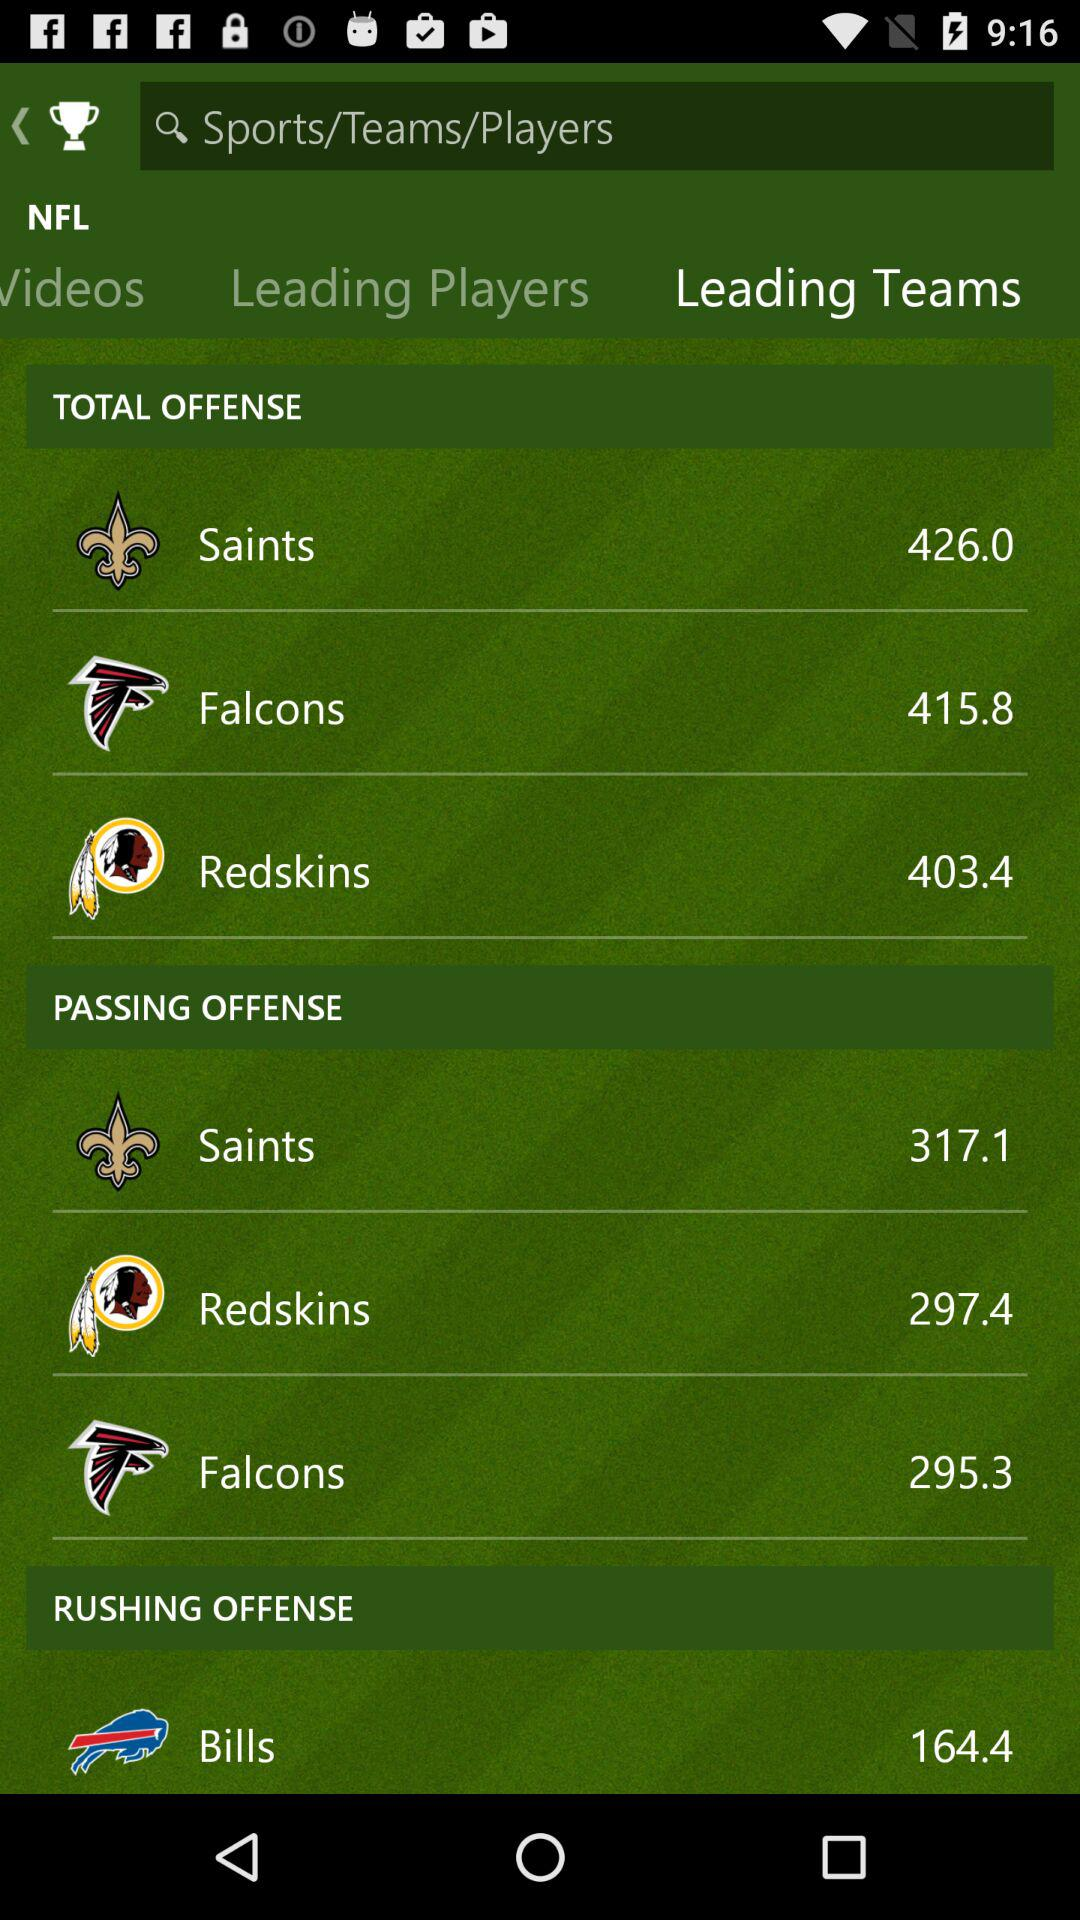How many total offences are committed by the Saints? The total offences committed by the Saints is 426.0. 